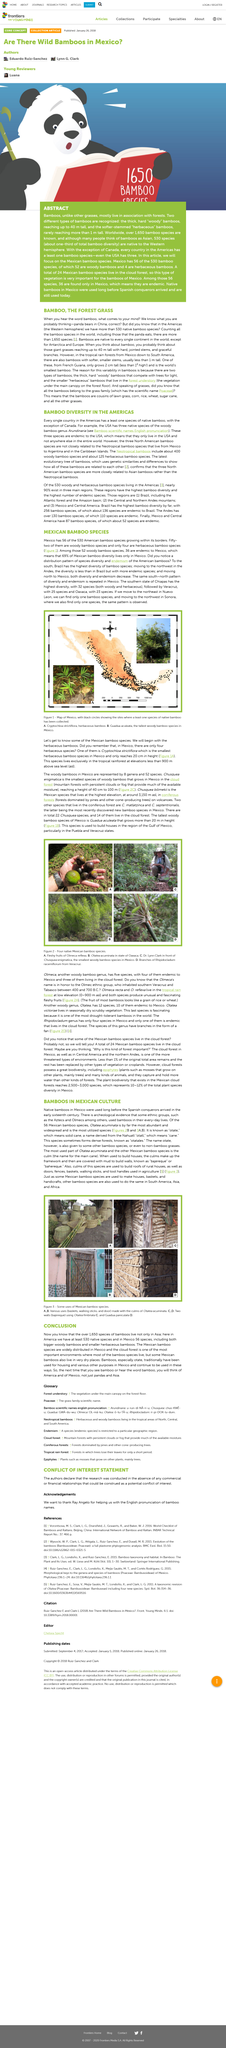Identify some key points in this picture. There are at least 530 native species found in America. There exist both bigger woody bamboos and smaller herbaceous bamboos in Mexico. Bamboos have been traditionally used in Mexico for housing and various other purposes, providing a sustainable and versatile material for the country's inhabitants. 